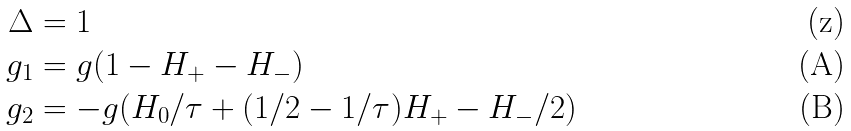<formula> <loc_0><loc_0><loc_500><loc_500>\Delta & = 1 \\ g _ { 1 } & = g ( 1 - H _ { + } - H _ { - } ) \\ g _ { 2 } & = - g ( H _ { 0 } / \tau + ( 1 / 2 - 1 / \tau ) H _ { + } - H _ { - } / 2 )</formula> 